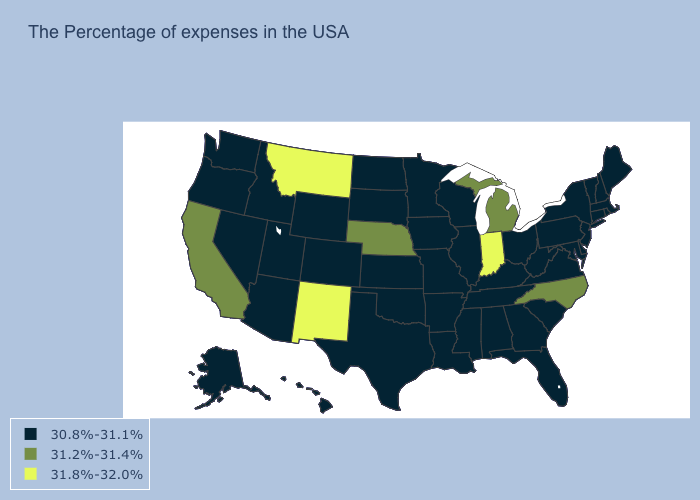What is the value of Minnesota?
Be succinct. 30.8%-31.1%. Name the states that have a value in the range 31.2%-31.4%?
Give a very brief answer. North Carolina, Michigan, Nebraska, California. Among the states that border Georgia , does North Carolina have the lowest value?
Write a very short answer. No. Name the states that have a value in the range 30.8%-31.1%?
Keep it brief. Maine, Massachusetts, Rhode Island, New Hampshire, Vermont, Connecticut, New York, New Jersey, Delaware, Maryland, Pennsylvania, Virginia, South Carolina, West Virginia, Ohio, Florida, Georgia, Kentucky, Alabama, Tennessee, Wisconsin, Illinois, Mississippi, Louisiana, Missouri, Arkansas, Minnesota, Iowa, Kansas, Oklahoma, Texas, South Dakota, North Dakota, Wyoming, Colorado, Utah, Arizona, Idaho, Nevada, Washington, Oregon, Alaska, Hawaii. Among the states that border Utah , which have the highest value?
Write a very short answer. New Mexico. Does the first symbol in the legend represent the smallest category?
Give a very brief answer. Yes. What is the lowest value in the USA?
Write a very short answer. 30.8%-31.1%. What is the value of Mississippi?
Answer briefly. 30.8%-31.1%. Among the states that border Missouri , which have the lowest value?
Keep it brief. Kentucky, Tennessee, Illinois, Arkansas, Iowa, Kansas, Oklahoma. Among the states that border Virginia , which have the lowest value?
Give a very brief answer. Maryland, West Virginia, Kentucky, Tennessee. Is the legend a continuous bar?
Write a very short answer. No. Does Montana have the lowest value in the USA?
Write a very short answer. No. What is the value of Minnesota?
Quick response, please. 30.8%-31.1%. 